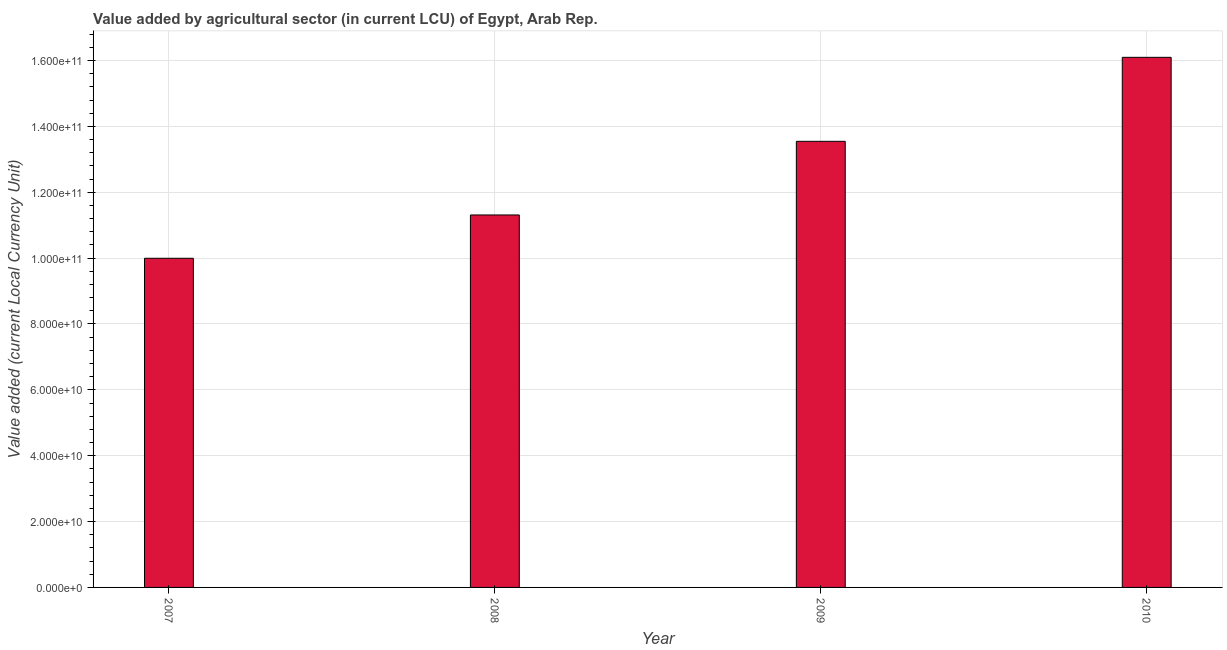Does the graph contain any zero values?
Keep it short and to the point. No. Does the graph contain grids?
Give a very brief answer. Yes. What is the title of the graph?
Offer a very short reply. Value added by agricultural sector (in current LCU) of Egypt, Arab Rep. What is the label or title of the X-axis?
Your answer should be compact. Year. What is the label or title of the Y-axis?
Your answer should be compact. Value added (current Local Currency Unit). What is the value added by agriculture sector in 2009?
Provide a succinct answer. 1.35e+11. Across all years, what is the maximum value added by agriculture sector?
Make the answer very short. 1.61e+11. Across all years, what is the minimum value added by agriculture sector?
Offer a very short reply. 1.00e+11. In which year was the value added by agriculture sector minimum?
Keep it short and to the point. 2007. What is the sum of the value added by agriculture sector?
Offer a terse response. 5.09e+11. What is the difference between the value added by agriculture sector in 2008 and 2010?
Your answer should be very brief. -4.79e+1. What is the average value added by agriculture sector per year?
Give a very brief answer. 1.27e+11. What is the median value added by agriculture sector?
Offer a terse response. 1.24e+11. Do a majority of the years between 2010 and 2007 (inclusive) have value added by agriculture sector greater than 60000000000 LCU?
Offer a terse response. Yes. What is the ratio of the value added by agriculture sector in 2008 to that in 2009?
Provide a succinct answer. 0.83. What is the difference between the highest and the second highest value added by agriculture sector?
Your answer should be very brief. 2.55e+1. What is the difference between the highest and the lowest value added by agriculture sector?
Offer a terse response. 6.10e+1. How many bars are there?
Ensure brevity in your answer.  4. What is the difference between two consecutive major ticks on the Y-axis?
Provide a short and direct response. 2.00e+1. What is the Value added (current Local Currency Unit) of 2007?
Your answer should be very brief. 1.00e+11. What is the Value added (current Local Currency Unit) of 2008?
Provide a succinct answer. 1.13e+11. What is the Value added (current Local Currency Unit) of 2009?
Provide a succinct answer. 1.35e+11. What is the Value added (current Local Currency Unit) of 2010?
Your answer should be very brief. 1.61e+11. What is the difference between the Value added (current Local Currency Unit) in 2007 and 2008?
Make the answer very short. -1.32e+1. What is the difference between the Value added (current Local Currency Unit) in 2007 and 2009?
Provide a succinct answer. -3.55e+1. What is the difference between the Value added (current Local Currency Unit) in 2007 and 2010?
Provide a succinct answer. -6.10e+1. What is the difference between the Value added (current Local Currency Unit) in 2008 and 2009?
Provide a short and direct response. -2.24e+1. What is the difference between the Value added (current Local Currency Unit) in 2008 and 2010?
Provide a short and direct response. -4.79e+1. What is the difference between the Value added (current Local Currency Unit) in 2009 and 2010?
Provide a succinct answer. -2.55e+1. What is the ratio of the Value added (current Local Currency Unit) in 2007 to that in 2008?
Your answer should be very brief. 0.88. What is the ratio of the Value added (current Local Currency Unit) in 2007 to that in 2009?
Offer a terse response. 0.74. What is the ratio of the Value added (current Local Currency Unit) in 2007 to that in 2010?
Your answer should be very brief. 0.62. What is the ratio of the Value added (current Local Currency Unit) in 2008 to that in 2009?
Ensure brevity in your answer.  0.83. What is the ratio of the Value added (current Local Currency Unit) in 2008 to that in 2010?
Give a very brief answer. 0.7. What is the ratio of the Value added (current Local Currency Unit) in 2009 to that in 2010?
Offer a very short reply. 0.84. 